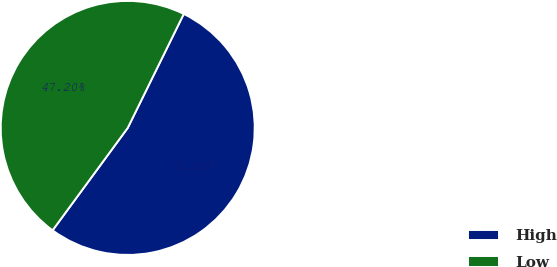Convert chart. <chart><loc_0><loc_0><loc_500><loc_500><pie_chart><fcel>High<fcel>Low<nl><fcel>52.8%<fcel>47.2%<nl></chart> 